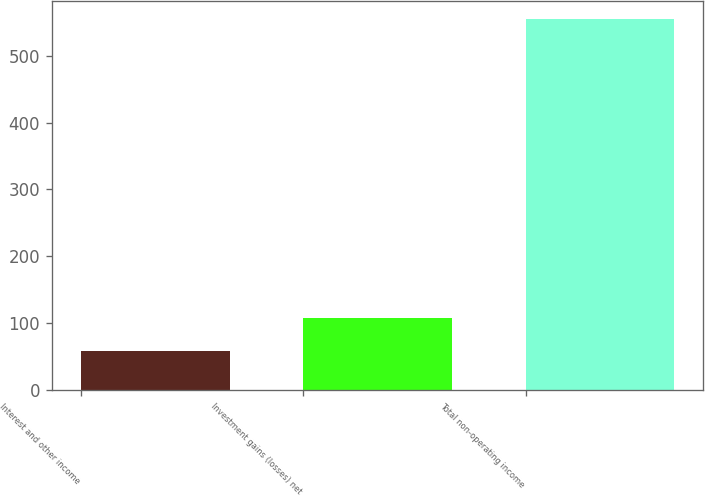Convert chart to OTSL. <chart><loc_0><loc_0><loc_500><loc_500><bar_chart><fcel>Interest and other income<fcel>Investment gains (losses) net<fcel>Total non-operating income<nl><fcel>58<fcel>107.6<fcel>554<nl></chart> 